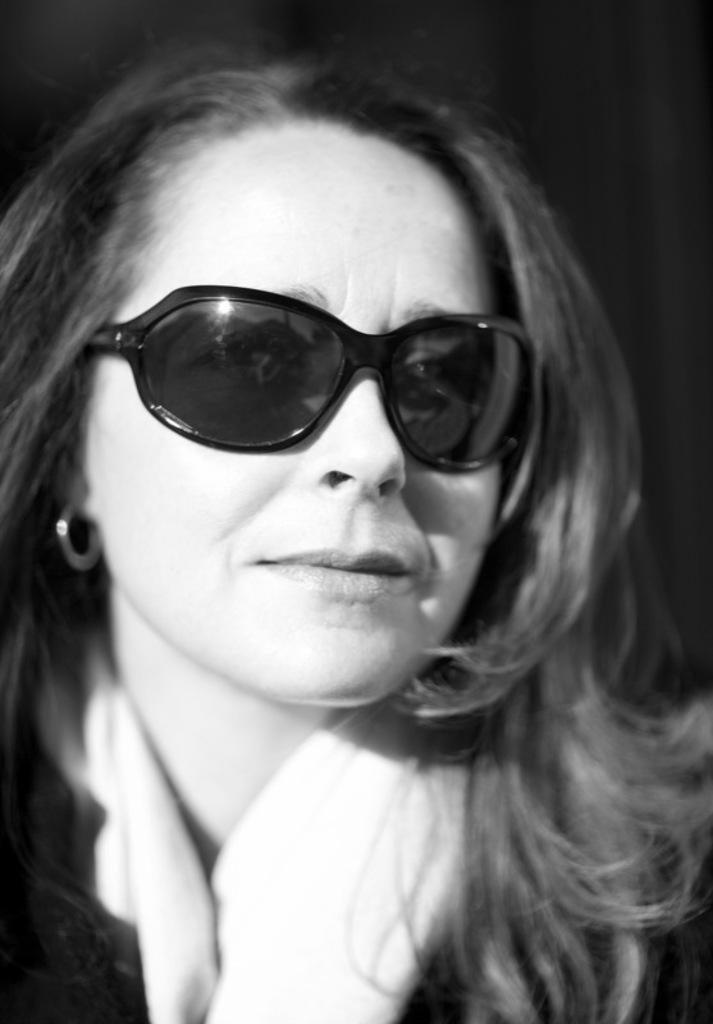Who is the main subject in the image? There is a woman in the image. What accessory is the woman wearing in the image? The woman is wearing sunglasses. What is the color scheme of the image? The image is in black and white color. What type of paste is the woman using to stick the porter's notebook in the image? There is no paste, porter, or notebook present in the image. 